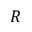Convert formula to latex. <formula><loc_0><loc_0><loc_500><loc_500>R</formula> 